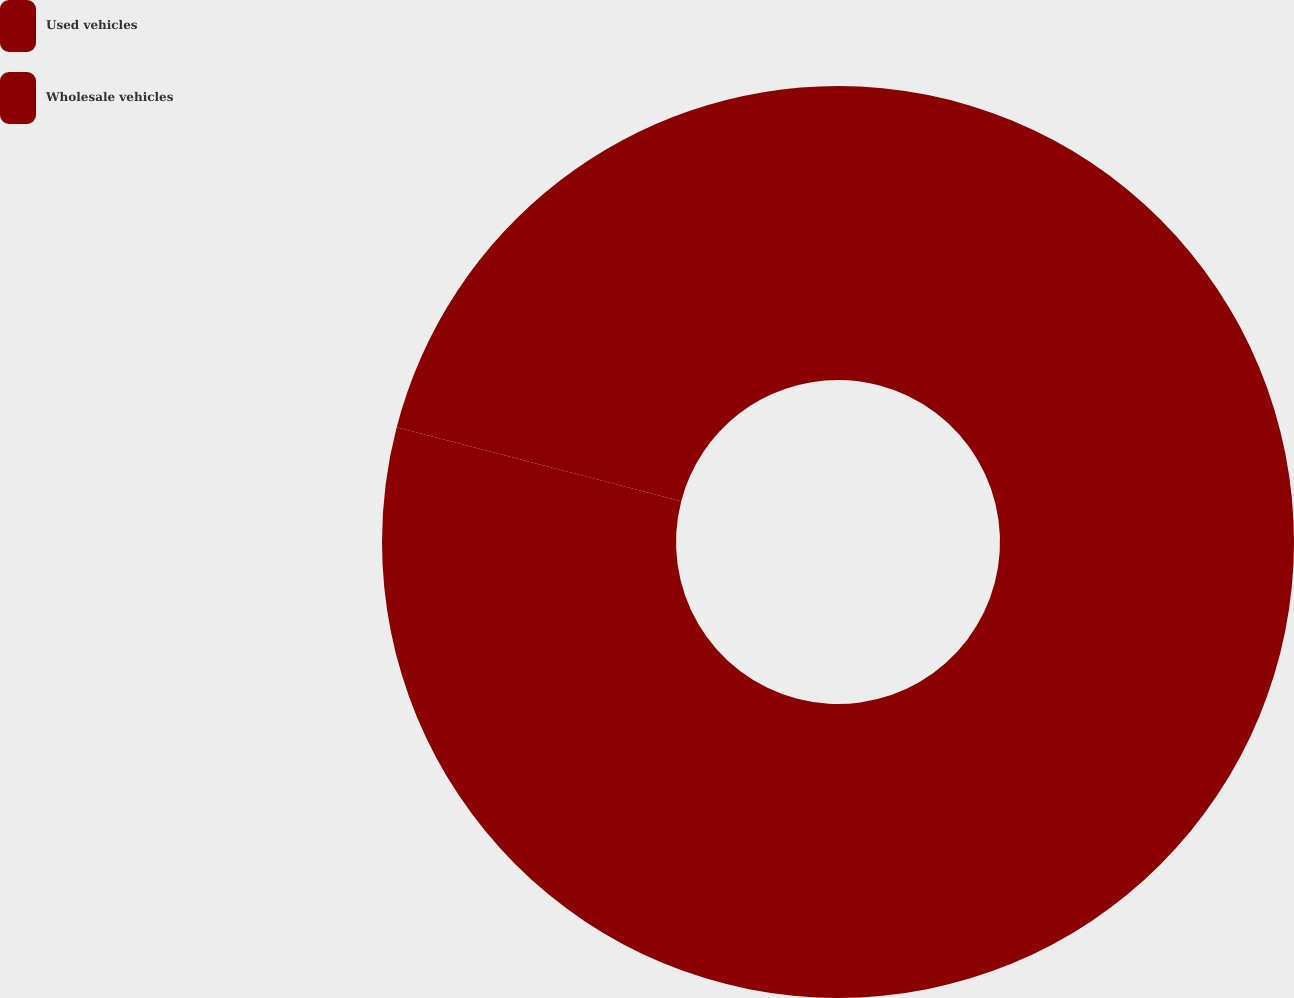Convert chart to OTSL. <chart><loc_0><loc_0><loc_500><loc_500><pie_chart><fcel>Used vehicles<fcel>Wholesale vehicles<nl><fcel>79.05%<fcel>20.95%<nl></chart> 